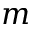Convert formula to latex. <formula><loc_0><loc_0><loc_500><loc_500>m</formula> 